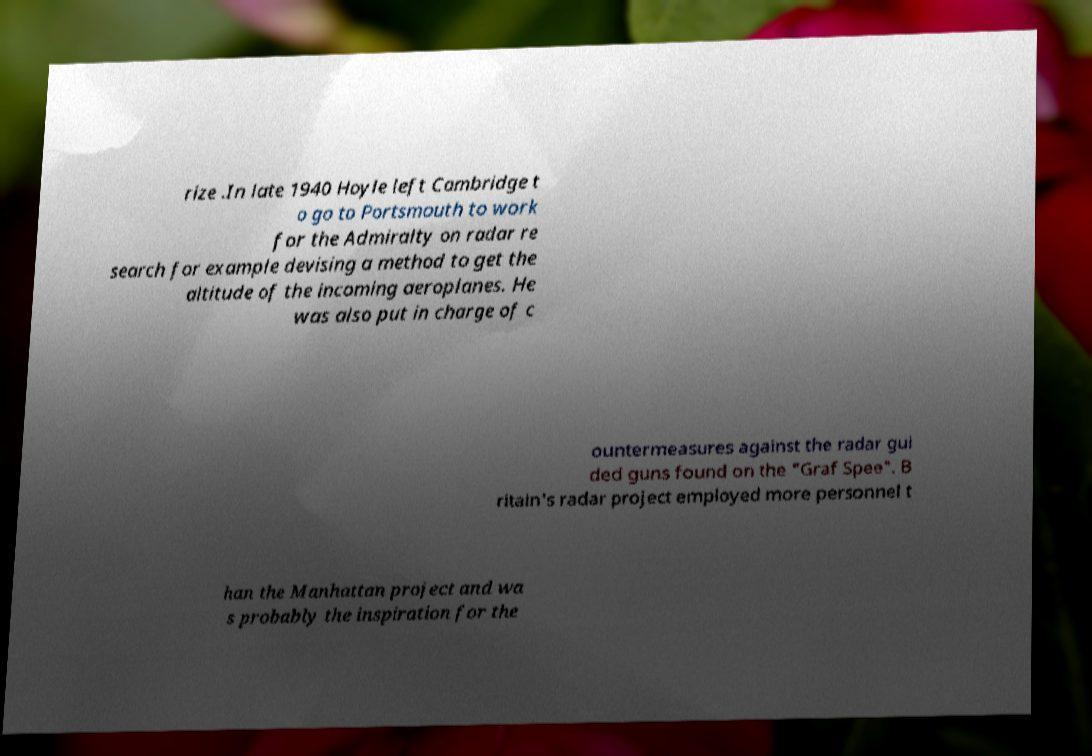Could you assist in decoding the text presented in this image and type it out clearly? rize .In late 1940 Hoyle left Cambridge t o go to Portsmouth to work for the Admiralty on radar re search for example devising a method to get the altitude of the incoming aeroplanes. He was also put in charge of c ountermeasures against the radar gui ded guns found on the "Graf Spee". B ritain's radar project employed more personnel t han the Manhattan project and wa s probably the inspiration for the 